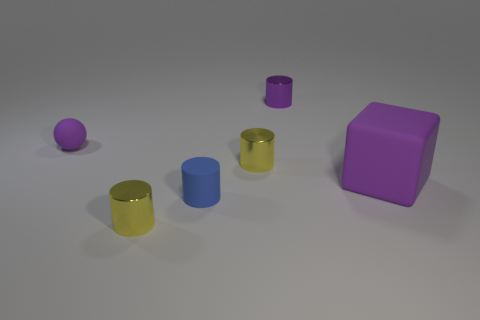Subtract all cyan blocks. How many yellow cylinders are left? 2 Add 4 small green blocks. How many objects exist? 10 Subtract all purple cylinders. How many cylinders are left? 3 Subtract all purple cylinders. How many cylinders are left? 3 Subtract all cylinders. How many objects are left? 2 Subtract 0 green cylinders. How many objects are left? 6 Subtract all cyan balls. Subtract all purple cubes. How many balls are left? 1 Subtract all large rubber things. Subtract all blue cylinders. How many objects are left? 4 Add 4 yellow metal cylinders. How many yellow metal cylinders are left? 6 Add 4 tiny brown cubes. How many tiny brown cubes exist? 4 